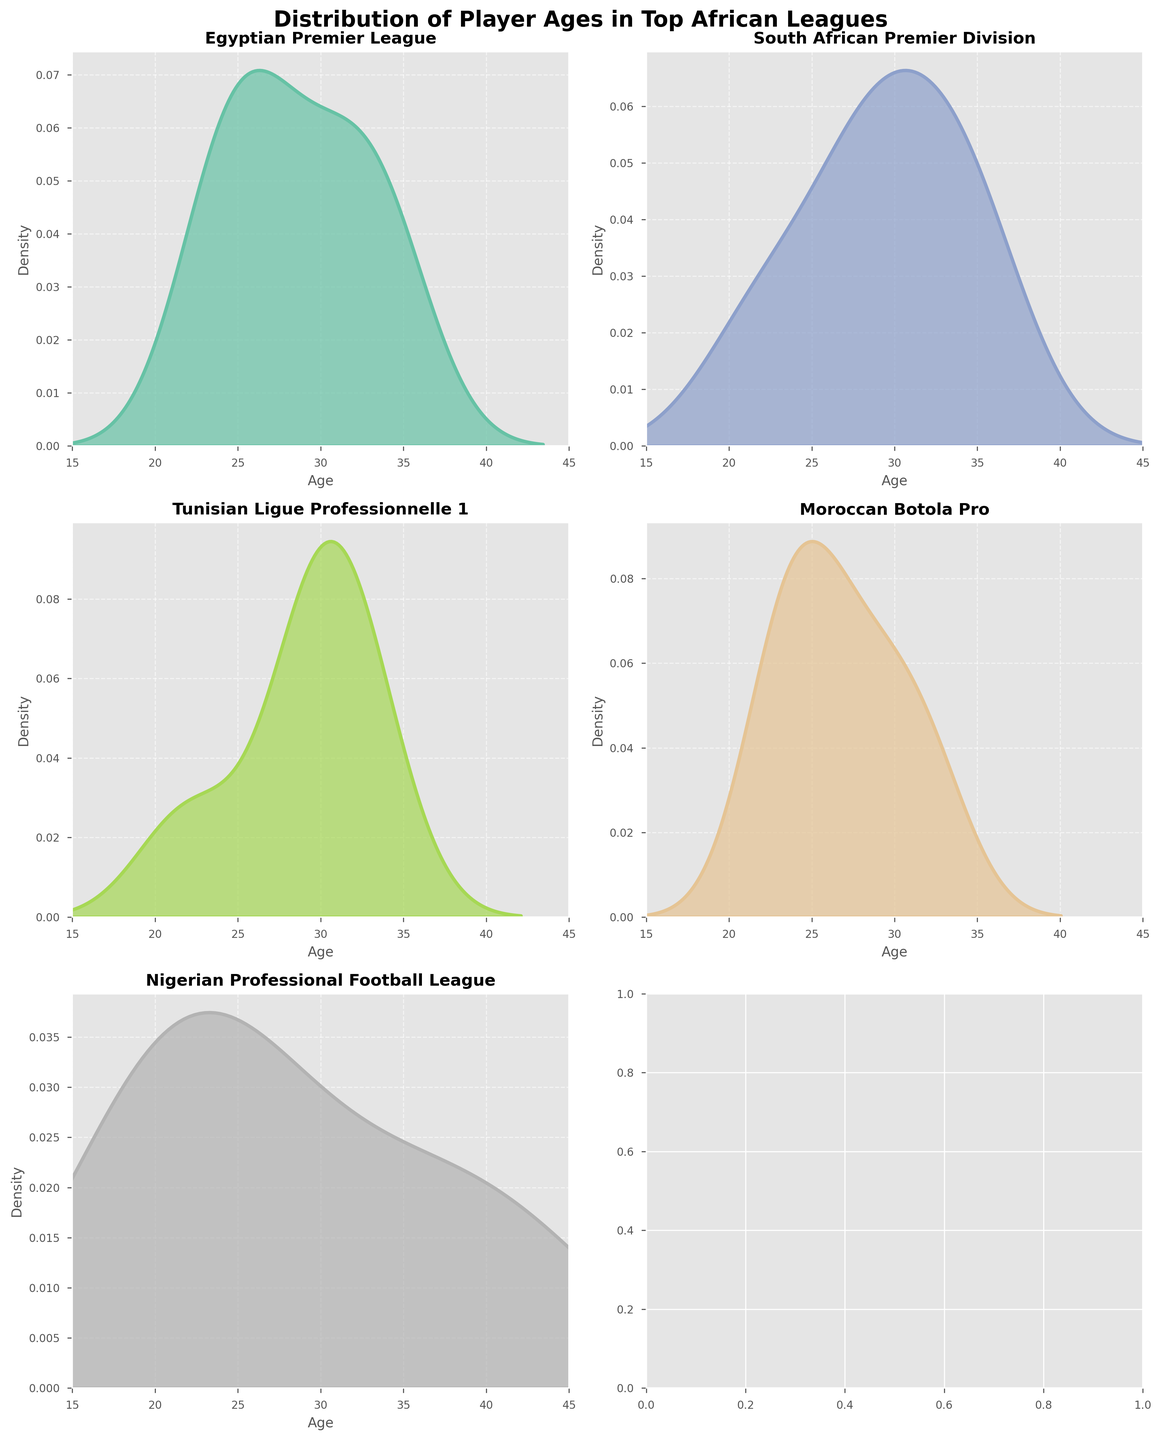How many subplots are there in the figure? There are six leagues in the data, and each subplot represents one league. The figure contains six subplots arranged in a 3x2 grid.
Answer: Six What's the color scheme used for the subplots? The figure uses a color palette from Set2 to represent each league. This palette consists of soft, pastel-like colors. Each league has its color for the density plot.
Answer: Soft pastel colors Which league has the widest range of ages? By observing the distribution spreads, the Nigerian Professional Football League's density plot shows a wider range compared to others, as it covers ages from around 20 to 42.
Answer: Nigerian Professional Football League Which league appears to have the youngest player distribution? The South African Premier Division's density plot is shifted more towards the left side (lower ages), indicating a younger player distribution.
Answer: South African Premier Division Which league shows the highest age density around 30 years? The Egyptian Premier League's density plot has a peak around the age of 30, indicating a higher density of players in that age range.
Answer: Egyptian Premier League In which league is there a player age peak around 22-23 years? The Moroccan Botola Pro shows a notable peak around the ages of 22-23 in its density plot, indicating many players in that age range.
Answer: Moroccan Botola Pro Compare the age distribution of Moroccan Botola Pro and Tunisian Ligue Professionnelle 1. Which one has older players on average? By comparing the density plots, the Tunisian Ligue Professionnelle 1 has a peak centered around higher ages (close to 30), indicating generally older players on average than the Moroccan Botola Pro.
Answer: Tunisian Ligue Professionnelle 1 Considering all leagues overall, which one has the most diverse age range? The Nigerian Professional Football League displays the most diverse age range, as evidenced by a wide spread from around 20 to above 40 years in the density plot.
Answer: Nigerian Professional Football League Identify the league with the fewest high-density areas. The South African Premier Division has a relatively flat density plot without significant peaks, indicating fewer high-density areas of player ages.
Answer: South African Premier Division 